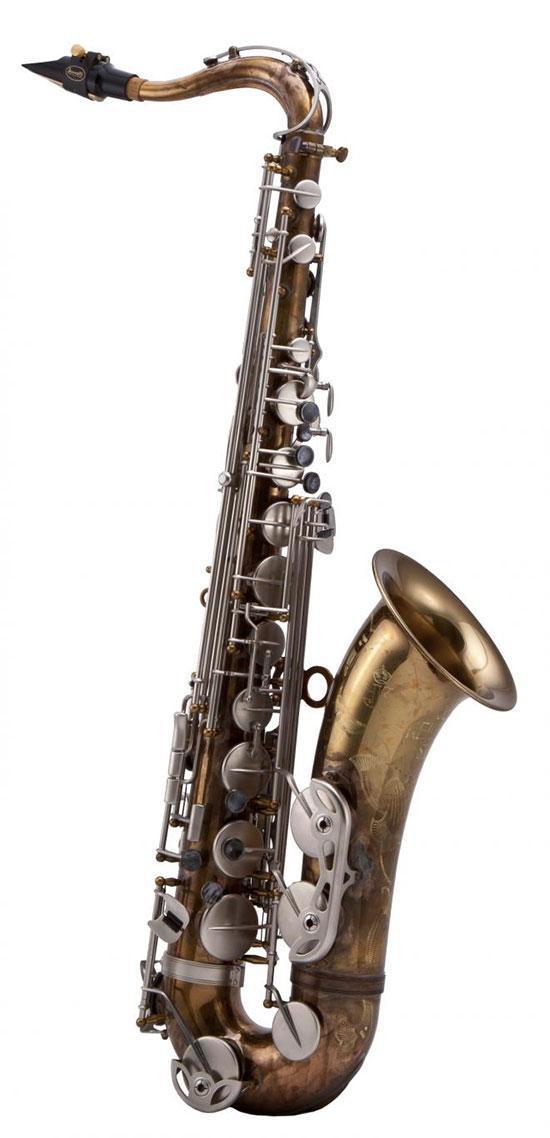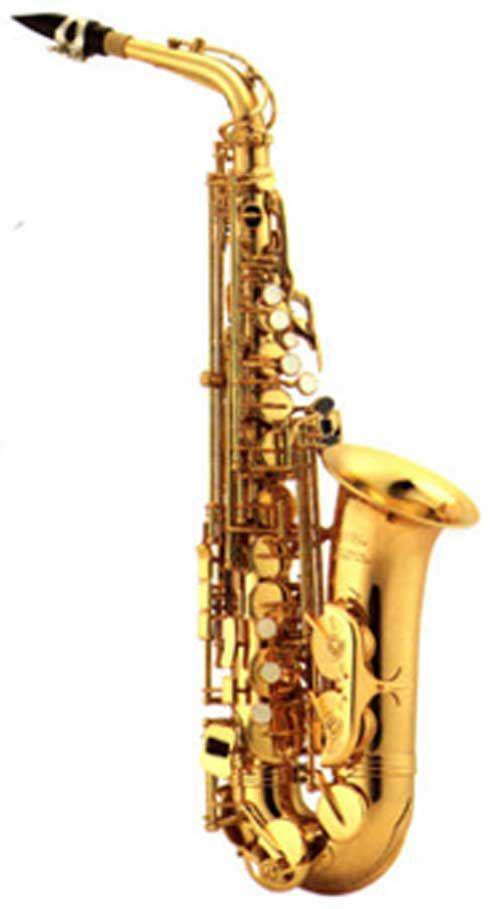The first image is the image on the left, the second image is the image on the right. Evaluate the accuracy of this statement regarding the images: "there is an instrument in its box, the box is lined in velvet and there is a bouch in the box with the instrument". Is it true? Answer yes or no. No. The first image is the image on the left, the second image is the image on the right. Considering the images on both sides, is "One image shows a saxophone, detached mouthpieces, and a black vinyl pouch in an open case lined with black velvet." valid? Answer yes or no. No. 